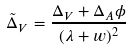<formula> <loc_0><loc_0><loc_500><loc_500>\tilde { \Delta } _ { V } = \frac { \Delta _ { V } + \Delta _ { A } \phi } { ( \lambda + w ) ^ { 2 } }</formula> 